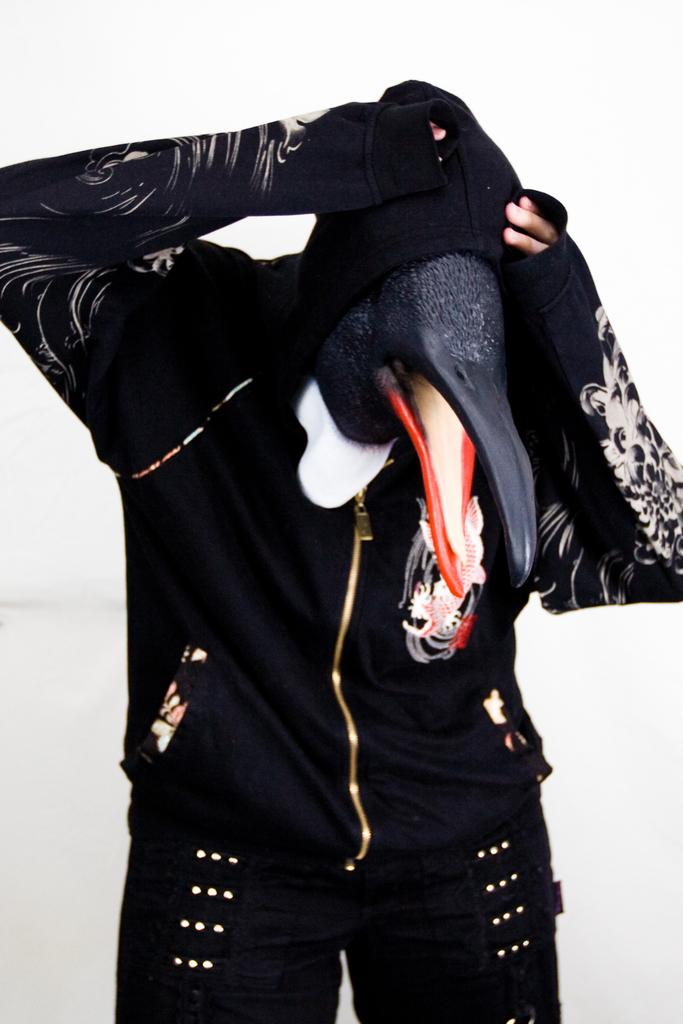Who or what is present in the image? There is a person in the image. What is unique about the person's appearance? The person is wearing a bird mask. What color is the jacket the person is wearing? The person is wearing a black color jacket. What type of pain can be seen on the person's face in the image? There is no indication of pain on the person's face in the image. 